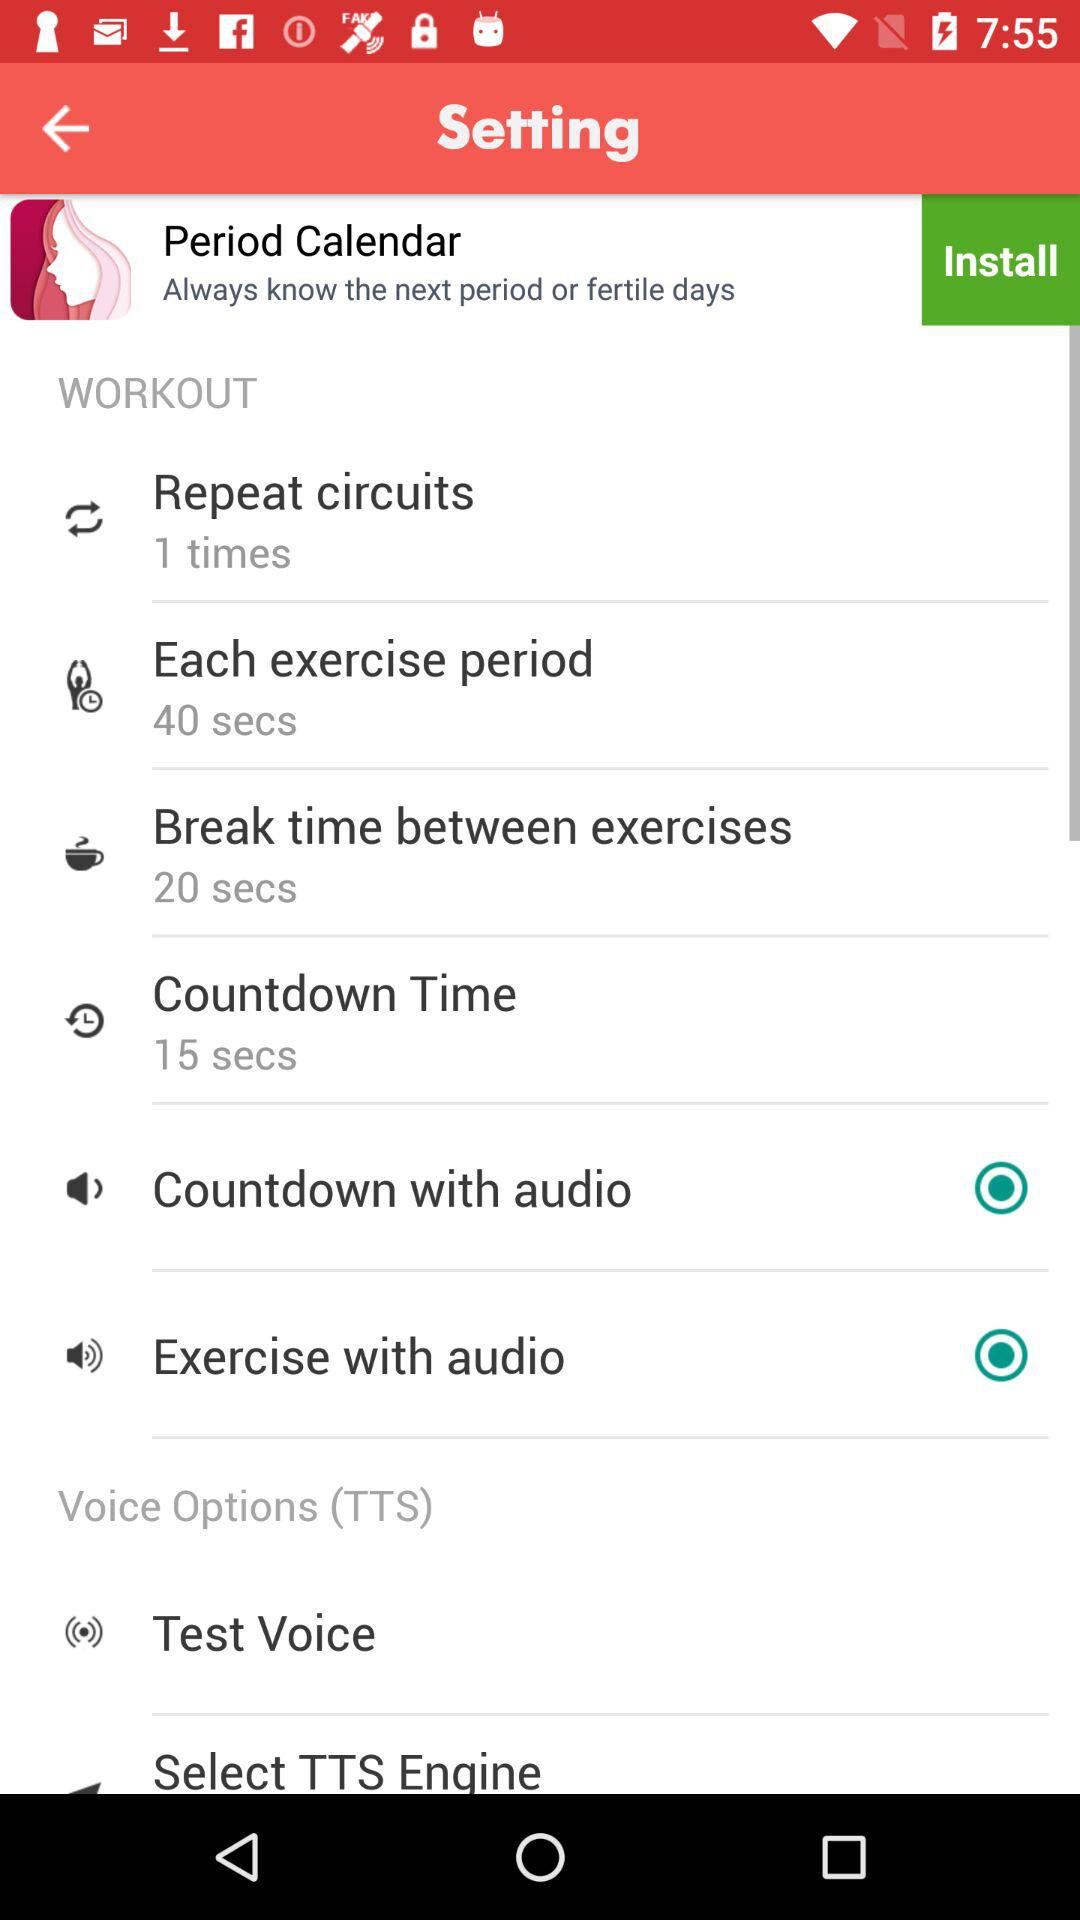What's the status of "Countdown with audio"? The status is "on". 